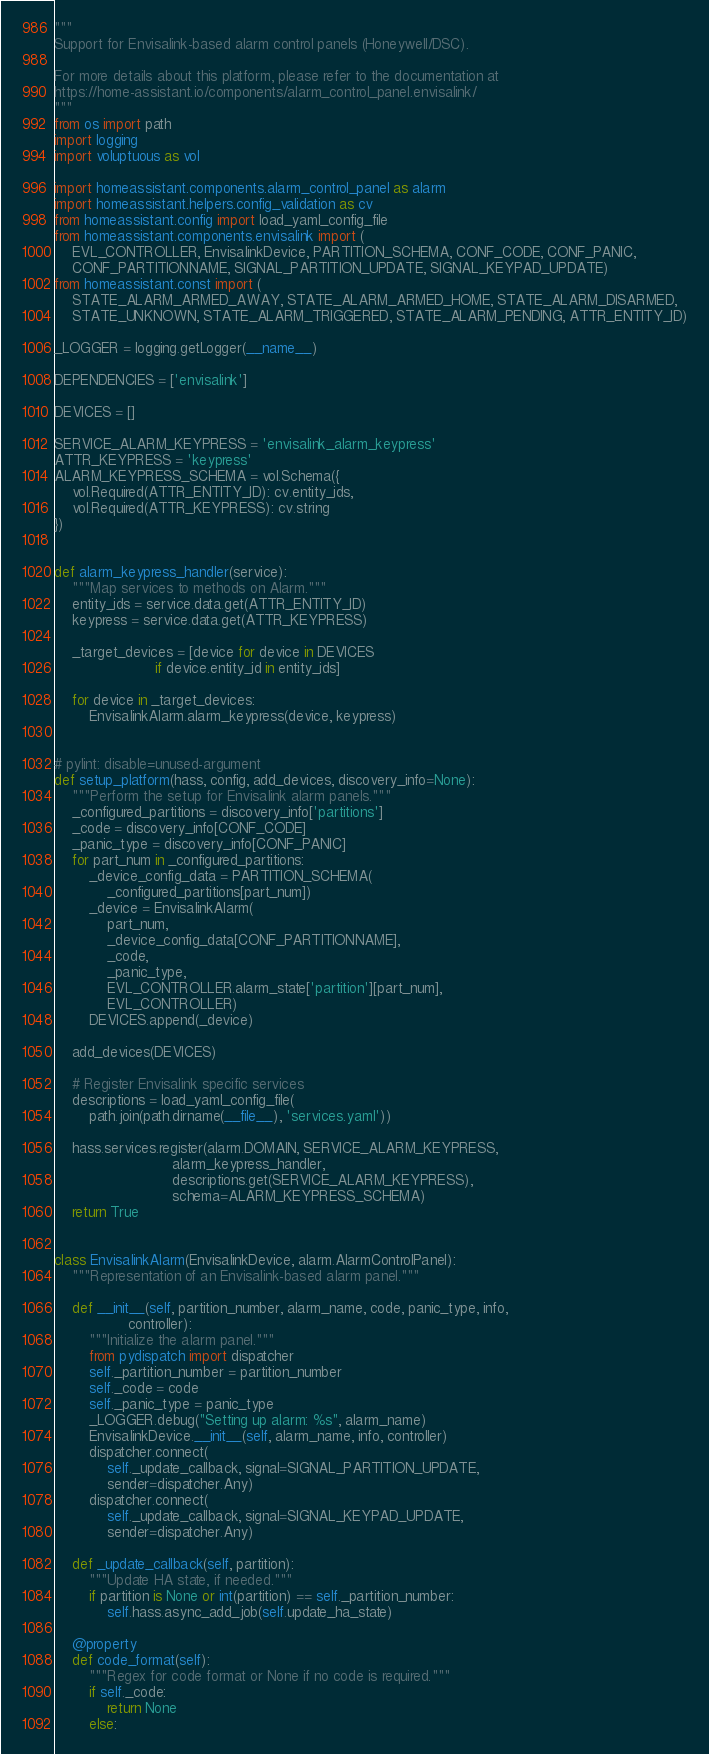<code> <loc_0><loc_0><loc_500><loc_500><_Python_>"""
Support for Envisalink-based alarm control panels (Honeywell/DSC).

For more details about this platform, please refer to the documentation at
https://home-assistant.io/components/alarm_control_panel.envisalink/
"""
from os import path
import logging
import voluptuous as vol

import homeassistant.components.alarm_control_panel as alarm
import homeassistant.helpers.config_validation as cv
from homeassistant.config import load_yaml_config_file
from homeassistant.components.envisalink import (
    EVL_CONTROLLER, EnvisalinkDevice, PARTITION_SCHEMA, CONF_CODE, CONF_PANIC,
    CONF_PARTITIONNAME, SIGNAL_PARTITION_UPDATE, SIGNAL_KEYPAD_UPDATE)
from homeassistant.const import (
    STATE_ALARM_ARMED_AWAY, STATE_ALARM_ARMED_HOME, STATE_ALARM_DISARMED,
    STATE_UNKNOWN, STATE_ALARM_TRIGGERED, STATE_ALARM_PENDING, ATTR_ENTITY_ID)

_LOGGER = logging.getLogger(__name__)

DEPENDENCIES = ['envisalink']

DEVICES = []

SERVICE_ALARM_KEYPRESS = 'envisalink_alarm_keypress'
ATTR_KEYPRESS = 'keypress'
ALARM_KEYPRESS_SCHEMA = vol.Schema({
    vol.Required(ATTR_ENTITY_ID): cv.entity_ids,
    vol.Required(ATTR_KEYPRESS): cv.string
})


def alarm_keypress_handler(service):
    """Map services to methods on Alarm."""
    entity_ids = service.data.get(ATTR_ENTITY_ID)
    keypress = service.data.get(ATTR_KEYPRESS)

    _target_devices = [device for device in DEVICES
                       if device.entity_id in entity_ids]

    for device in _target_devices:
        EnvisalinkAlarm.alarm_keypress(device, keypress)


# pylint: disable=unused-argument
def setup_platform(hass, config, add_devices, discovery_info=None):
    """Perform the setup for Envisalink alarm panels."""
    _configured_partitions = discovery_info['partitions']
    _code = discovery_info[CONF_CODE]
    _panic_type = discovery_info[CONF_PANIC]
    for part_num in _configured_partitions:
        _device_config_data = PARTITION_SCHEMA(
            _configured_partitions[part_num])
        _device = EnvisalinkAlarm(
            part_num,
            _device_config_data[CONF_PARTITIONNAME],
            _code,
            _panic_type,
            EVL_CONTROLLER.alarm_state['partition'][part_num],
            EVL_CONTROLLER)
        DEVICES.append(_device)

    add_devices(DEVICES)

    # Register Envisalink specific services
    descriptions = load_yaml_config_file(
        path.join(path.dirname(__file__), 'services.yaml'))

    hass.services.register(alarm.DOMAIN, SERVICE_ALARM_KEYPRESS,
                           alarm_keypress_handler,
                           descriptions.get(SERVICE_ALARM_KEYPRESS),
                           schema=ALARM_KEYPRESS_SCHEMA)
    return True


class EnvisalinkAlarm(EnvisalinkDevice, alarm.AlarmControlPanel):
    """Representation of an Envisalink-based alarm panel."""

    def __init__(self, partition_number, alarm_name, code, panic_type, info,
                 controller):
        """Initialize the alarm panel."""
        from pydispatch import dispatcher
        self._partition_number = partition_number
        self._code = code
        self._panic_type = panic_type
        _LOGGER.debug("Setting up alarm: %s", alarm_name)
        EnvisalinkDevice.__init__(self, alarm_name, info, controller)
        dispatcher.connect(
            self._update_callback, signal=SIGNAL_PARTITION_UPDATE,
            sender=dispatcher.Any)
        dispatcher.connect(
            self._update_callback, signal=SIGNAL_KEYPAD_UPDATE,
            sender=dispatcher.Any)

    def _update_callback(self, partition):
        """Update HA state, if needed."""
        if partition is None or int(partition) == self._partition_number:
            self.hass.async_add_job(self.update_ha_state)

    @property
    def code_format(self):
        """Regex for code format or None if no code is required."""
        if self._code:
            return None
        else:</code> 